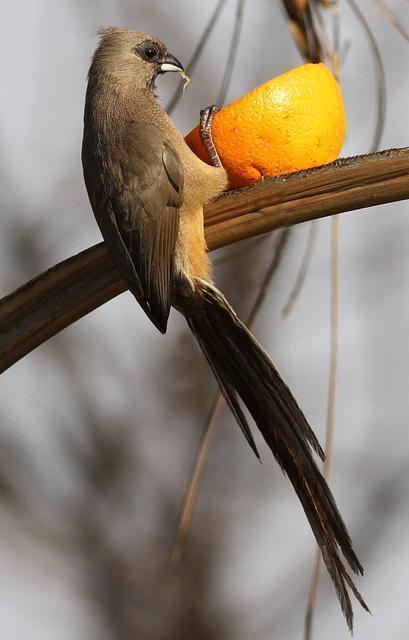How many birds are there?
Give a very brief answer. 1. How many taxi cars are in the image?
Give a very brief answer. 0. 